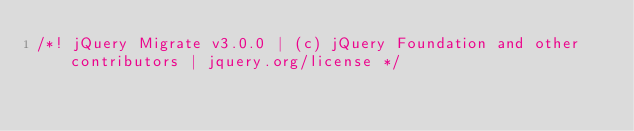Convert code to text. <code><loc_0><loc_0><loc_500><loc_500><_JavaScript_>/*! jQuery Migrate v3.0.0 | (c) jQuery Foundation and other contributors | jquery.org/license */</code> 